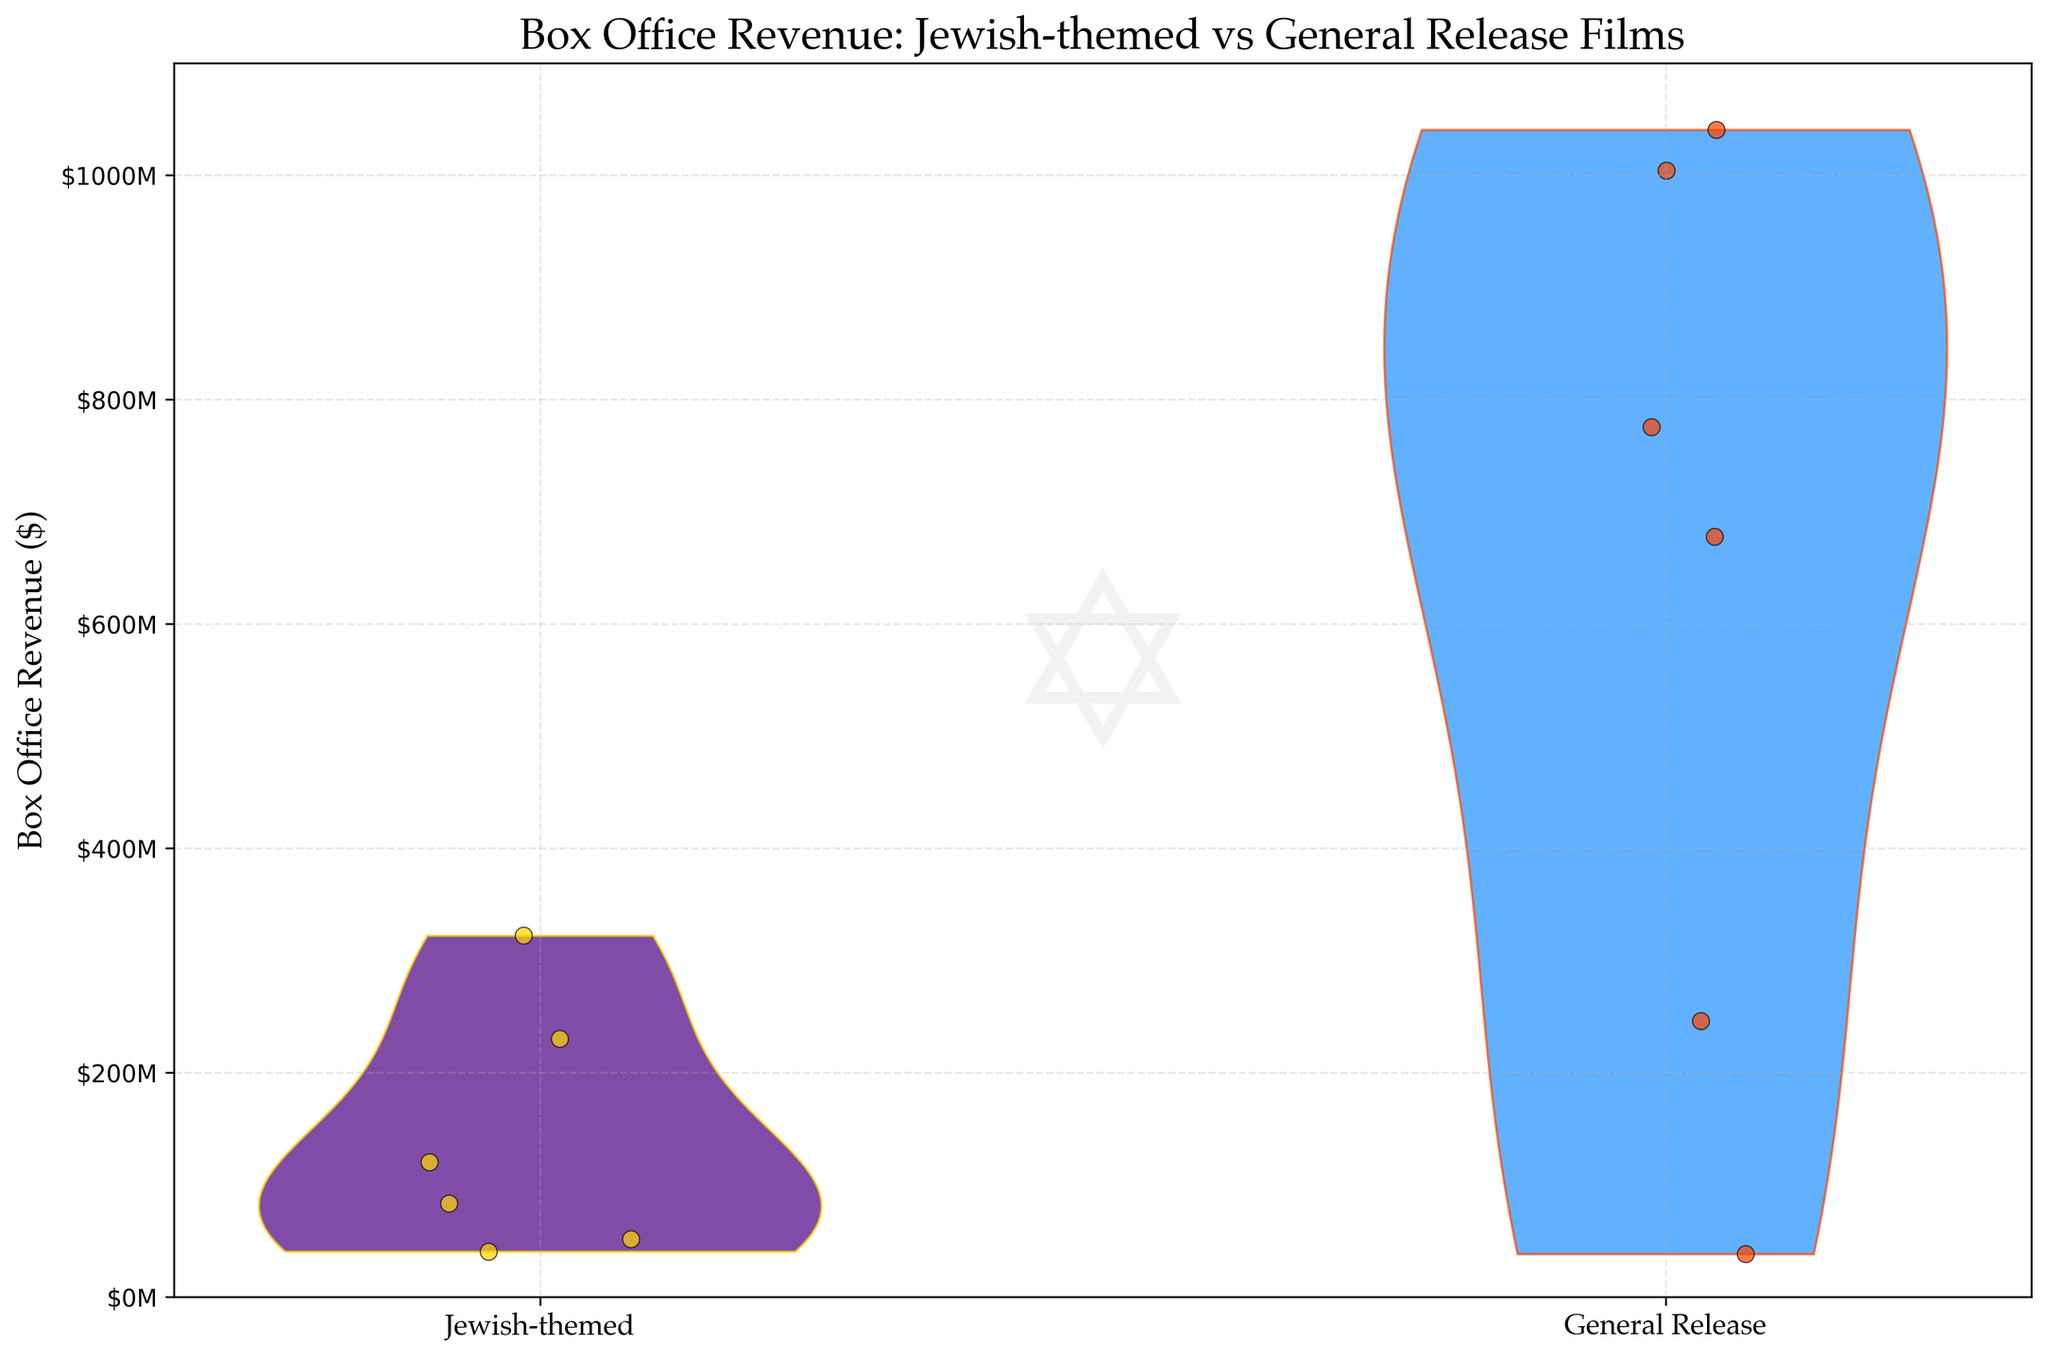How many main violin plots are present in the figure? The figure has two main violin plots, one representing Jewish-themed movies and the other representing general release films.
Answer: 2 What is the title of the figure? The title is located at the top of the figure, indicating the main subject. It reads "Box Office Revenue: Jewish-themed vs General Release Films."
Answer: Box Office Revenue: Jewish-themed vs General Release Films Which group shows higher box office revenue values, Jewish-themed movies or general release films? By observing the violin plots, the general release films have a higher spread, reaching above $1 billion, compared to Jewish-themed movies which have lower revenue values.
Answer: General release films What is the highest box office revenue recorded for Jewish-themed movies in the figure? The highest value can be identified by looking at the maximum point in the Jewish-themed violin plot, which corresponds to the movie "Schindler's List," with about $322 million.
Answer: $322 million What is the range of box office revenue for general release films displayed in the figure? The range can be determined by looking at the lowest and highest points of the general release violin plot. The data spans from around $38 million to over $1 billion.
Answer: $38 million to over $1 billion Which specific movie represents the highest box office revenue among Jewish-themed movies? This can be inferred by identifying the highest point within the Jewish-themed plot. The movie at that point is "Schindler's List."
Answer: Schindler's List How does the visual appearance of the violin plot for Jewish-themed movies differ from that of general release films? The Jewish-themed plot is colored in dark purple with gold edges, while the general release plot is in dodger blue with orange-red edges.
Answer: Different colors and edges How do the scatter plots of individual data points contribute to the visualization? The scatter points overlayed on the violin plots show individual movie revenues, providing specific data points like $322 million for "Schindler's List" and others closer to the violin's spread.
Answer: Shows individual values What is the maximum limit on the vertical axis and how is it formatted? The vertical axis extends up to $1.1 billion, formatted in millions (M), which helps to easily understand the revenue scale in millions of dollars.
Answer: $1.1 billion What additional visual element is included as a watermark and what might it signify? A subtle Star of David watermark is included, symbolizing the Jewish-themed context in part of the dataset.
Answer: Star of David 